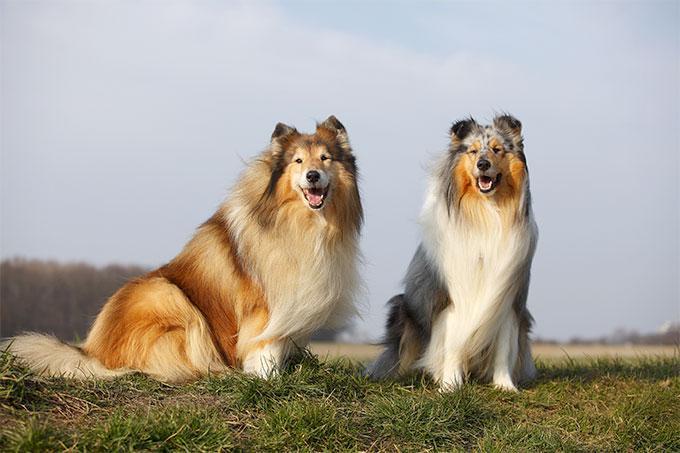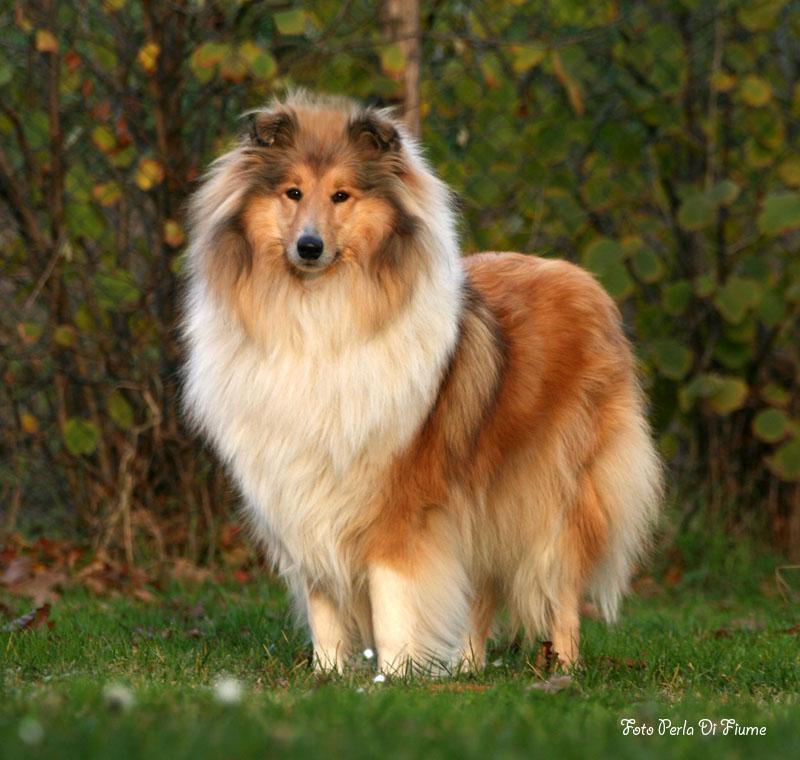The first image is the image on the left, the second image is the image on the right. Examine the images to the left and right. Is the description "One image shows a collie standing on grass, and the other is a portrait." accurate? Answer yes or no. No. 